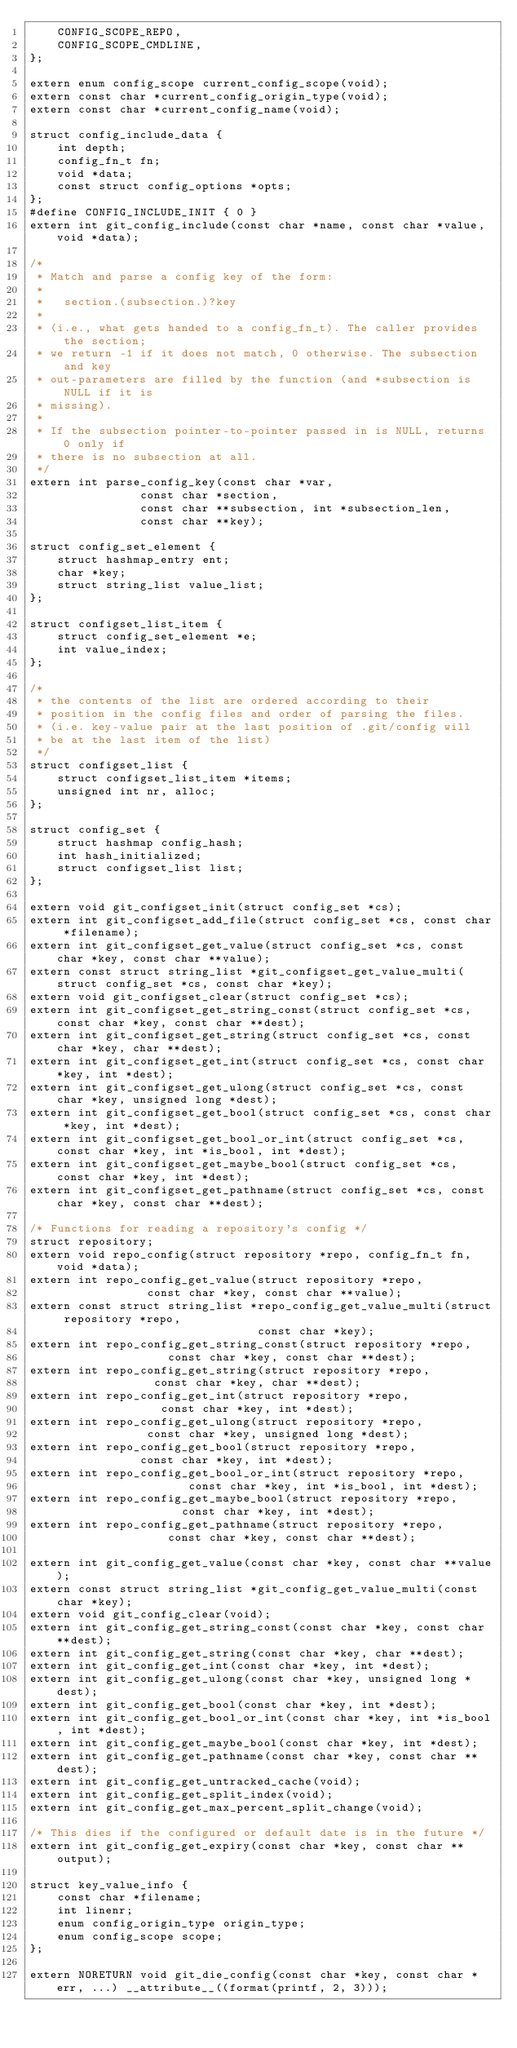<code> <loc_0><loc_0><loc_500><loc_500><_C_>	CONFIG_SCOPE_REPO,
	CONFIG_SCOPE_CMDLINE,
};

extern enum config_scope current_config_scope(void);
extern const char *current_config_origin_type(void);
extern const char *current_config_name(void);

struct config_include_data {
	int depth;
	config_fn_t fn;
	void *data;
	const struct config_options *opts;
};
#define CONFIG_INCLUDE_INIT { 0 }
extern int git_config_include(const char *name, const char *value, void *data);

/*
 * Match and parse a config key of the form:
 *
 *   section.(subsection.)?key
 *
 * (i.e., what gets handed to a config_fn_t). The caller provides the section;
 * we return -1 if it does not match, 0 otherwise. The subsection and key
 * out-parameters are filled by the function (and *subsection is NULL if it is
 * missing).
 *
 * If the subsection pointer-to-pointer passed in is NULL, returns 0 only if
 * there is no subsection at all.
 */
extern int parse_config_key(const char *var,
			    const char *section,
			    const char **subsection, int *subsection_len,
			    const char **key);

struct config_set_element {
	struct hashmap_entry ent;
	char *key;
	struct string_list value_list;
};

struct configset_list_item {
	struct config_set_element *e;
	int value_index;
};

/*
 * the contents of the list are ordered according to their
 * position in the config files and order of parsing the files.
 * (i.e. key-value pair at the last position of .git/config will
 * be at the last item of the list)
 */
struct configset_list {
	struct configset_list_item *items;
	unsigned int nr, alloc;
};

struct config_set {
	struct hashmap config_hash;
	int hash_initialized;
	struct configset_list list;
};

extern void git_configset_init(struct config_set *cs);
extern int git_configset_add_file(struct config_set *cs, const char *filename);
extern int git_configset_get_value(struct config_set *cs, const char *key, const char **value);
extern const struct string_list *git_configset_get_value_multi(struct config_set *cs, const char *key);
extern void git_configset_clear(struct config_set *cs);
extern int git_configset_get_string_const(struct config_set *cs, const char *key, const char **dest);
extern int git_configset_get_string(struct config_set *cs, const char *key, char **dest);
extern int git_configset_get_int(struct config_set *cs, const char *key, int *dest);
extern int git_configset_get_ulong(struct config_set *cs, const char *key, unsigned long *dest);
extern int git_configset_get_bool(struct config_set *cs, const char *key, int *dest);
extern int git_configset_get_bool_or_int(struct config_set *cs, const char *key, int *is_bool, int *dest);
extern int git_configset_get_maybe_bool(struct config_set *cs, const char *key, int *dest);
extern int git_configset_get_pathname(struct config_set *cs, const char *key, const char **dest);

/* Functions for reading a repository's config */
struct repository;
extern void repo_config(struct repository *repo, config_fn_t fn, void *data);
extern int repo_config_get_value(struct repository *repo,
				 const char *key, const char **value);
extern const struct string_list *repo_config_get_value_multi(struct repository *repo,
							     const char *key);
extern int repo_config_get_string_const(struct repository *repo,
					const char *key, const char **dest);
extern int repo_config_get_string(struct repository *repo,
				  const char *key, char **dest);
extern int repo_config_get_int(struct repository *repo,
			       const char *key, int *dest);
extern int repo_config_get_ulong(struct repository *repo,
				 const char *key, unsigned long *dest);
extern int repo_config_get_bool(struct repository *repo,
				const char *key, int *dest);
extern int repo_config_get_bool_or_int(struct repository *repo,
				       const char *key, int *is_bool, int *dest);
extern int repo_config_get_maybe_bool(struct repository *repo,
				      const char *key, int *dest);
extern int repo_config_get_pathname(struct repository *repo,
				    const char *key, const char **dest);

extern int git_config_get_value(const char *key, const char **value);
extern const struct string_list *git_config_get_value_multi(const char *key);
extern void git_config_clear(void);
extern int git_config_get_string_const(const char *key, const char **dest);
extern int git_config_get_string(const char *key, char **dest);
extern int git_config_get_int(const char *key, int *dest);
extern int git_config_get_ulong(const char *key, unsigned long *dest);
extern int git_config_get_bool(const char *key, int *dest);
extern int git_config_get_bool_or_int(const char *key, int *is_bool, int *dest);
extern int git_config_get_maybe_bool(const char *key, int *dest);
extern int git_config_get_pathname(const char *key, const char **dest);
extern int git_config_get_untracked_cache(void);
extern int git_config_get_split_index(void);
extern int git_config_get_max_percent_split_change(void);

/* This dies if the configured or default date is in the future */
extern int git_config_get_expiry(const char *key, const char **output);

struct key_value_info {
	const char *filename;
	int linenr;
	enum config_origin_type origin_type;
	enum config_scope scope;
};

extern NORETURN void git_die_config(const char *key, const char *err, ...) __attribute__((format(printf, 2, 3)));</code> 